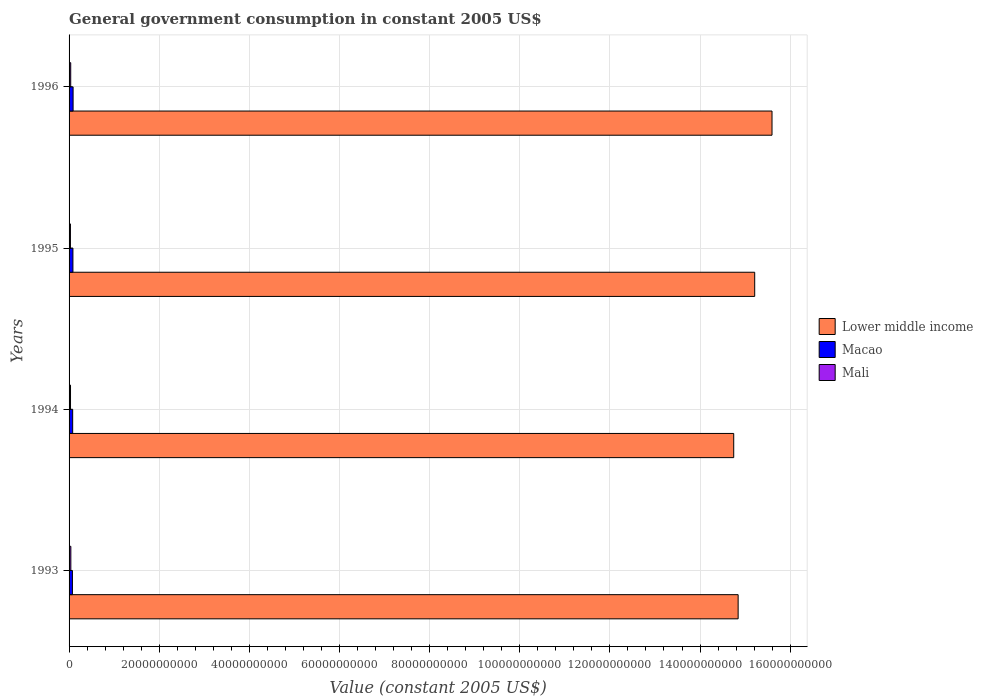How many groups of bars are there?
Your answer should be very brief. 4. What is the label of the 3rd group of bars from the top?
Your answer should be very brief. 1994. In how many cases, is the number of bars for a given year not equal to the number of legend labels?
Keep it short and to the point. 0. What is the government conusmption in Macao in 1995?
Offer a terse response. 8.54e+08. Across all years, what is the maximum government conusmption in Mali?
Your response must be concise. 3.94e+08. Across all years, what is the minimum government conusmption in Lower middle income?
Offer a very short reply. 1.47e+11. In which year was the government conusmption in Lower middle income maximum?
Give a very brief answer. 1996. In which year was the government conusmption in Mali minimum?
Your response must be concise. 1995. What is the total government conusmption in Mali in the graph?
Keep it short and to the point. 1.38e+09. What is the difference between the government conusmption in Lower middle income in 1993 and that in 1995?
Offer a very short reply. -3.68e+09. What is the difference between the government conusmption in Lower middle income in 1994 and the government conusmption in Mali in 1995?
Offer a very short reply. 1.47e+11. What is the average government conusmption in Mali per year?
Keep it short and to the point. 3.45e+08. In the year 1994, what is the difference between the government conusmption in Macao and government conusmption in Mali?
Your answer should be compact. 4.77e+08. In how many years, is the government conusmption in Mali greater than 116000000000 US$?
Your answer should be compact. 0. What is the ratio of the government conusmption in Macao in 1993 to that in 1996?
Give a very brief answer. 0.84. Is the government conusmption in Macao in 1994 less than that in 1996?
Your answer should be very brief. Yes. What is the difference between the highest and the second highest government conusmption in Macao?
Make the answer very short. 3.84e+07. What is the difference between the highest and the lowest government conusmption in Macao?
Provide a short and direct response. 1.47e+08. Is the sum of the government conusmption in Macao in 1995 and 1996 greater than the maximum government conusmption in Lower middle income across all years?
Give a very brief answer. No. What does the 2nd bar from the top in 1996 represents?
Provide a succinct answer. Macao. What does the 2nd bar from the bottom in 1996 represents?
Your answer should be very brief. Macao. How many bars are there?
Offer a terse response. 12. How many years are there in the graph?
Your answer should be very brief. 4. What is the difference between two consecutive major ticks on the X-axis?
Your answer should be very brief. 2.00e+1. Are the values on the major ticks of X-axis written in scientific E-notation?
Your answer should be compact. No. Does the graph contain grids?
Provide a short and direct response. Yes. Where does the legend appear in the graph?
Provide a short and direct response. Center right. How many legend labels are there?
Your answer should be compact. 3. What is the title of the graph?
Make the answer very short. General government consumption in constant 2005 US$. What is the label or title of the X-axis?
Ensure brevity in your answer.  Value (constant 2005 US$). What is the label or title of the Y-axis?
Your answer should be compact. Years. What is the Value (constant 2005 US$) of Lower middle income in 1993?
Offer a terse response. 1.48e+11. What is the Value (constant 2005 US$) in Macao in 1993?
Offer a very short reply. 7.45e+08. What is the Value (constant 2005 US$) in Mali in 1993?
Your answer should be compact. 3.94e+08. What is the Value (constant 2005 US$) in Lower middle income in 1994?
Offer a very short reply. 1.47e+11. What is the Value (constant 2005 US$) of Macao in 1994?
Give a very brief answer. 7.99e+08. What is the Value (constant 2005 US$) of Mali in 1994?
Keep it short and to the point. 3.21e+08. What is the Value (constant 2005 US$) in Lower middle income in 1995?
Provide a short and direct response. 1.52e+11. What is the Value (constant 2005 US$) in Macao in 1995?
Ensure brevity in your answer.  8.54e+08. What is the Value (constant 2005 US$) in Mali in 1995?
Make the answer very short. 3.02e+08. What is the Value (constant 2005 US$) in Lower middle income in 1996?
Make the answer very short. 1.56e+11. What is the Value (constant 2005 US$) of Macao in 1996?
Your answer should be compact. 8.92e+08. What is the Value (constant 2005 US$) of Mali in 1996?
Make the answer very short. 3.65e+08. Across all years, what is the maximum Value (constant 2005 US$) in Lower middle income?
Make the answer very short. 1.56e+11. Across all years, what is the maximum Value (constant 2005 US$) of Macao?
Provide a short and direct response. 8.92e+08. Across all years, what is the maximum Value (constant 2005 US$) in Mali?
Your answer should be very brief. 3.94e+08. Across all years, what is the minimum Value (constant 2005 US$) of Lower middle income?
Make the answer very short. 1.47e+11. Across all years, what is the minimum Value (constant 2005 US$) in Macao?
Give a very brief answer. 7.45e+08. Across all years, what is the minimum Value (constant 2005 US$) in Mali?
Provide a short and direct response. 3.02e+08. What is the total Value (constant 2005 US$) of Lower middle income in the graph?
Offer a terse response. 6.04e+11. What is the total Value (constant 2005 US$) in Macao in the graph?
Offer a terse response. 3.29e+09. What is the total Value (constant 2005 US$) in Mali in the graph?
Provide a succinct answer. 1.38e+09. What is the difference between the Value (constant 2005 US$) in Lower middle income in 1993 and that in 1994?
Provide a succinct answer. 9.81e+08. What is the difference between the Value (constant 2005 US$) of Macao in 1993 and that in 1994?
Give a very brief answer. -5.37e+07. What is the difference between the Value (constant 2005 US$) of Mali in 1993 and that in 1994?
Provide a succinct answer. 7.22e+07. What is the difference between the Value (constant 2005 US$) of Lower middle income in 1993 and that in 1995?
Your answer should be very brief. -3.68e+09. What is the difference between the Value (constant 2005 US$) in Macao in 1993 and that in 1995?
Offer a very short reply. -1.09e+08. What is the difference between the Value (constant 2005 US$) in Mali in 1993 and that in 1995?
Give a very brief answer. 9.19e+07. What is the difference between the Value (constant 2005 US$) in Lower middle income in 1993 and that in 1996?
Keep it short and to the point. -7.52e+09. What is the difference between the Value (constant 2005 US$) in Macao in 1993 and that in 1996?
Ensure brevity in your answer.  -1.47e+08. What is the difference between the Value (constant 2005 US$) in Mali in 1993 and that in 1996?
Give a very brief answer. 2.86e+07. What is the difference between the Value (constant 2005 US$) of Lower middle income in 1994 and that in 1995?
Make the answer very short. -4.66e+09. What is the difference between the Value (constant 2005 US$) in Macao in 1994 and that in 1995?
Provide a short and direct response. -5.51e+07. What is the difference between the Value (constant 2005 US$) in Mali in 1994 and that in 1995?
Your answer should be very brief. 1.97e+07. What is the difference between the Value (constant 2005 US$) in Lower middle income in 1994 and that in 1996?
Your answer should be very brief. -8.50e+09. What is the difference between the Value (constant 2005 US$) of Macao in 1994 and that in 1996?
Your answer should be compact. -9.35e+07. What is the difference between the Value (constant 2005 US$) in Mali in 1994 and that in 1996?
Your answer should be compact. -4.36e+07. What is the difference between the Value (constant 2005 US$) of Lower middle income in 1995 and that in 1996?
Ensure brevity in your answer.  -3.84e+09. What is the difference between the Value (constant 2005 US$) in Macao in 1995 and that in 1996?
Ensure brevity in your answer.  -3.84e+07. What is the difference between the Value (constant 2005 US$) of Mali in 1995 and that in 1996?
Ensure brevity in your answer.  -6.33e+07. What is the difference between the Value (constant 2005 US$) of Lower middle income in 1993 and the Value (constant 2005 US$) of Macao in 1994?
Provide a succinct answer. 1.48e+11. What is the difference between the Value (constant 2005 US$) in Lower middle income in 1993 and the Value (constant 2005 US$) in Mali in 1994?
Your answer should be compact. 1.48e+11. What is the difference between the Value (constant 2005 US$) in Macao in 1993 and the Value (constant 2005 US$) in Mali in 1994?
Your answer should be very brief. 4.24e+08. What is the difference between the Value (constant 2005 US$) in Lower middle income in 1993 and the Value (constant 2005 US$) in Macao in 1995?
Provide a short and direct response. 1.48e+11. What is the difference between the Value (constant 2005 US$) of Lower middle income in 1993 and the Value (constant 2005 US$) of Mali in 1995?
Provide a succinct answer. 1.48e+11. What is the difference between the Value (constant 2005 US$) in Macao in 1993 and the Value (constant 2005 US$) in Mali in 1995?
Your answer should be compact. 4.44e+08. What is the difference between the Value (constant 2005 US$) of Lower middle income in 1993 and the Value (constant 2005 US$) of Macao in 1996?
Your answer should be very brief. 1.48e+11. What is the difference between the Value (constant 2005 US$) of Lower middle income in 1993 and the Value (constant 2005 US$) of Mali in 1996?
Offer a very short reply. 1.48e+11. What is the difference between the Value (constant 2005 US$) of Macao in 1993 and the Value (constant 2005 US$) of Mali in 1996?
Provide a succinct answer. 3.80e+08. What is the difference between the Value (constant 2005 US$) in Lower middle income in 1994 and the Value (constant 2005 US$) in Macao in 1995?
Make the answer very short. 1.47e+11. What is the difference between the Value (constant 2005 US$) in Lower middle income in 1994 and the Value (constant 2005 US$) in Mali in 1995?
Make the answer very short. 1.47e+11. What is the difference between the Value (constant 2005 US$) of Macao in 1994 and the Value (constant 2005 US$) of Mali in 1995?
Your answer should be compact. 4.97e+08. What is the difference between the Value (constant 2005 US$) of Lower middle income in 1994 and the Value (constant 2005 US$) of Macao in 1996?
Offer a terse response. 1.47e+11. What is the difference between the Value (constant 2005 US$) of Lower middle income in 1994 and the Value (constant 2005 US$) of Mali in 1996?
Your answer should be very brief. 1.47e+11. What is the difference between the Value (constant 2005 US$) of Macao in 1994 and the Value (constant 2005 US$) of Mali in 1996?
Offer a terse response. 4.34e+08. What is the difference between the Value (constant 2005 US$) of Lower middle income in 1995 and the Value (constant 2005 US$) of Macao in 1996?
Give a very brief answer. 1.51e+11. What is the difference between the Value (constant 2005 US$) in Lower middle income in 1995 and the Value (constant 2005 US$) in Mali in 1996?
Your answer should be very brief. 1.52e+11. What is the difference between the Value (constant 2005 US$) of Macao in 1995 and the Value (constant 2005 US$) of Mali in 1996?
Provide a succinct answer. 4.89e+08. What is the average Value (constant 2005 US$) of Lower middle income per year?
Offer a very short reply. 1.51e+11. What is the average Value (constant 2005 US$) of Macao per year?
Ensure brevity in your answer.  8.23e+08. What is the average Value (constant 2005 US$) in Mali per year?
Your answer should be very brief. 3.45e+08. In the year 1993, what is the difference between the Value (constant 2005 US$) in Lower middle income and Value (constant 2005 US$) in Macao?
Make the answer very short. 1.48e+11. In the year 1993, what is the difference between the Value (constant 2005 US$) in Lower middle income and Value (constant 2005 US$) in Mali?
Your answer should be very brief. 1.48e+11. In the year 1993, what is the difference between the Value (constant 2005 US$) of Macao and Value (constant 2005 US$) of Mali?
Your response must be concise. 3.52e+08. In the year 1994, what is the difference between the Value (constant 2005 US$) of Lower middle income and Value (constant 2005 US$) of Macao?
Ensure brevity in your answer.  1.47e+11. In the year 1994, what is the difference between the Value (constant 2005 US$) of Lower middle income and Value (constant 2005 US$) of Mali?
Provide a short and direct response. 1.47e+11. In the year 1994, what is the difference between the Value (constant 2005 US$) of Macao and Value (constant 2005 US$) of Mali?
Keep it short and to the point. 4.77e+08. In the year 1995, what is the difference between the Value (constant 2005 US$) in Lower middle income and Value (constant 2005 US$) in Macao?
Make the answer very short. 1.51e+11. In the year 1995, what is the difference between the Value (constant 2005 US$) of Lower middle income and Value (constant 2005 US$) of Mali?
Offer a very short reply. 1.52e+11. In the year 1995, what is the difference between the Value (constant 2005 US$) of Macao and Value (constant 2005 US$) of Mali?
Provide a short and direct response. 5.52e+08. In the year 1996, what is the difference between the Value (constant 2005 US$) of Lower middle income and Value (constant 2005 US$) of Macao?
Provide a succinct answer. 1.55e+11. In the year 1996, what is the difference between the Value (constant 2005 US$) in Lower middle income and Value (constant 2005 US$) in Mali?
Provide a short and direct response. 1.56e+11. In the year 1996, what is the difference between the Value (constant 2005 US$) of Macao and Value (constant 2005 US$) of Mali?
Your answer should be compact. 5.27e+08. What is the ratio of the Value (constant 2005 US$) in Macao in 1993 to that in 1994?
Offer a very short reply. 0.93. What is the ratio of the Value (constant 2005 US$) of Mali in 1993 to that in 1994?
Provide a succinct answer. 1.22. What is the ratio of the Value (constant 2005 US$) in Lower middle income in 1993 to that in 1995?
Keep it short and to the point. 0.98. What is the ratio of the Value (constant 2005 US$) in Macao in 1993 to that in 1995?
Offer a terse response. 0.87. What is the ratio of the Value (constant 2005 US$) of Mali in 1993 to that in 1995?
Make the answer very short. 1.3. What is the ratio of the Value (constant 2005 US$) of Lower middle income in 1993 to that in 1996?
Give a very brief answer. 0.95. What is the ratio of the Value (constant 2005 US$) of Macao in 1993 to that in 1996?
Ensure brevity in your answer.  0.83. What is the ratio of the Value (constant 2005 US$) of Mali in 1993 to that in 1996?
Your response must be concise. 1.08. What is the ratio of the Value (constant 2005 US$) in Lower middle income in 1994 to that in 1995?
Provide a short and direct response. 0.97. What is the ratio of the Value (constant 2005 US$) in Macao in 1994 to that in 1995?
Offer a very short reply. 0.94. What is the ratio of the Value (constant 2005 US$) of Mali in 1994 to that in 1995?
Give a very brief answer. 1.07. What is the ratio of the Value (constant 2005 US$) of Lower middle income in 1994 to that in 1996?
Offer a very short reply. 0.95. What is the ratio of the Value (constant 2005 US$) in Macao in 1994 to that in 1996?
Keep it short and to the point. 0.9. What is the ratio of the Value (constant 2005 US$) of Mali in 1994 to that in 1996?
Give a very brief answer. 0.88. What is the ratio of the Value (constant 2005 US$) in Lower middle income in 1995 to that in 1996?
Provide a succinct answer. 0.98. What is the ratio of the Value (constant 2005 US$) in Macao in 1995 to that in 1996?
Provide a succinct answer. 0.96. What is the ratio of the Value (constant 2005 US$) of Mali in 1995 to that in 1996?
Ensure brevity in your answer.  0.83. What is the difference between the highest and the second highest Value (constant 2005 US$) in Lower middle income?
Your answer should be very brief. 3.84e+09. What is the difference between the highest and the second highest Value (constant 2005 US$) of Macao?
Offer a very short reply. 3.84e+07. What is the difference between the highest and the second highest Value (constant 2005 US$) in Mali?
Offer a very short reply. 2.86e+07. What is the difference between the highest and the lowest Value (constant 2005 US$) in Lower middle income?
Give a very brief answer. 8.50e+09. What is the difference between the highest and the lowest Value (constant 2005 US$) in Macao?
Your response must be concise. 1.47e+08. What is the difference between the highest and the lowest Value (constant 2005 US$) in Mali?
Your response must be concise. 9.19e+07. 